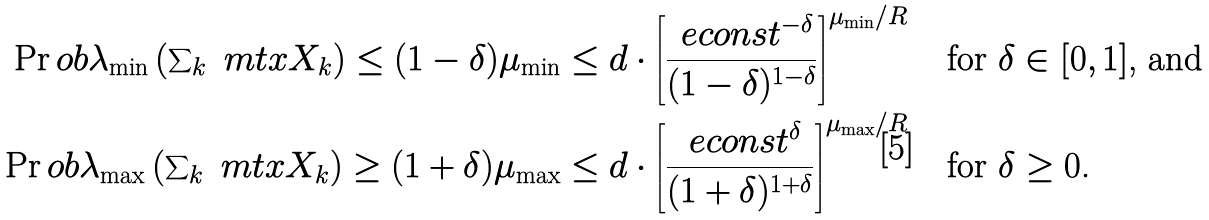<formula> <loc_0><loc_0><loc_500><loc_500>\Pr o b { \lambda _ { \min } \left ( \sum \nolimits _ { k } \ m t x { X } _ { k } \right ) \leq ( 1 - \delta ) \mu _ { \min } } & \leq d \cdot \left [ \frac { \ e c o n s t ^ { - \delta } } { ( 1 - \delta ) ^ { 1 - \delta } } \right ] ^ { \mu _ { \min } / R } \quad \text {for $\delta \in [0, 1]$, and} \\ \Pr o b { \lambda _ { \max } \left ( \sum \nolimits _ { k } \ m t x { X } _ { k } \right ) \geq ( 1 + \delta ) \mu _ { \max } } & \leq d \cdot \left [ \frac { \ e c o n s t ^ { \delta } } { ( 1 + \delta ) ^ { 1 + \delta } } \right ] ^ { \mu _ { \max } / R } \quad \text {for $\delta \geq 0$.}</formula> 